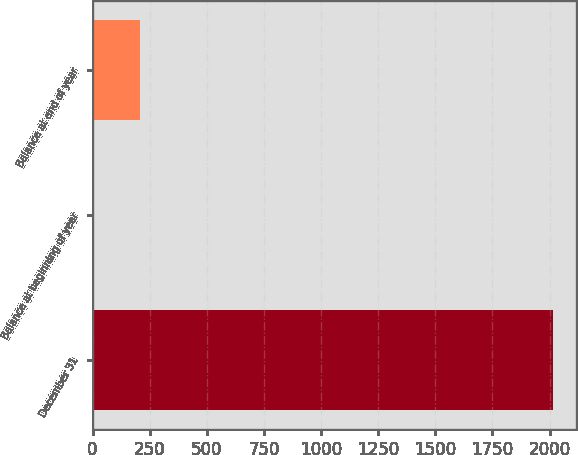Convert chart. <chart><loc_0><loc_0><loc_500><loc_500><bar_chart><fcel>December 31<fcel>Balance at beginning of year<fcel>Balance at end of year<nl><fcel>2015<fcel>7<fcel>207.8<nl></chart> 